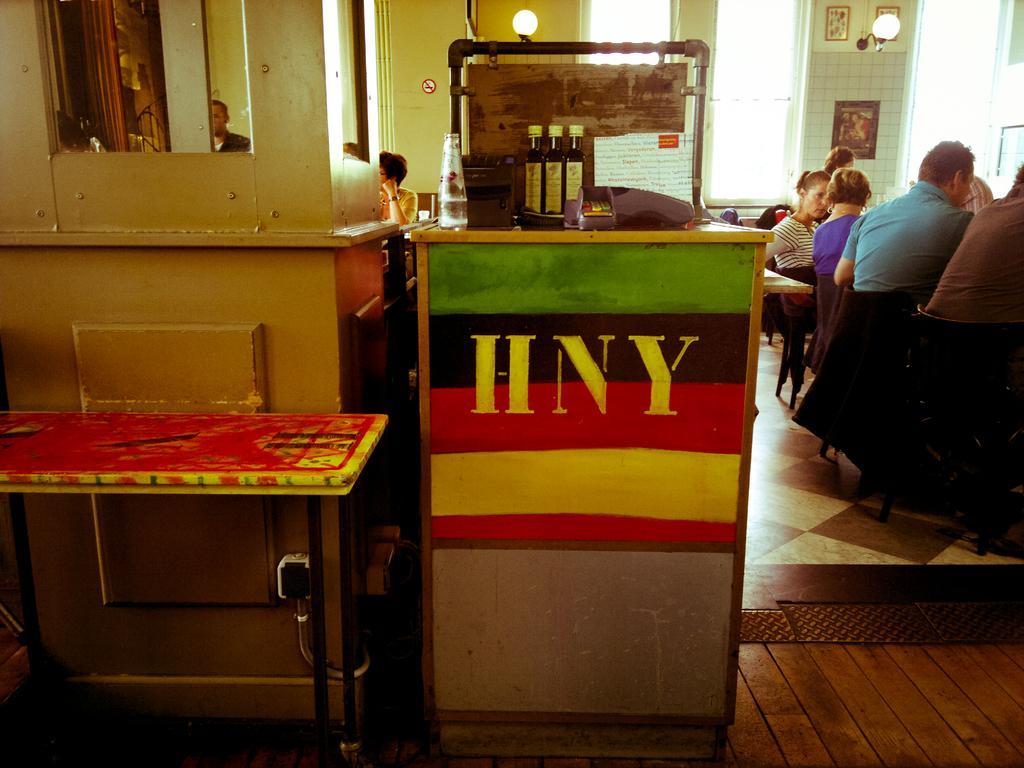Describe this image in one or two sentences. There is a wooden table which has some objects on it and there are some people beside and behind it. 